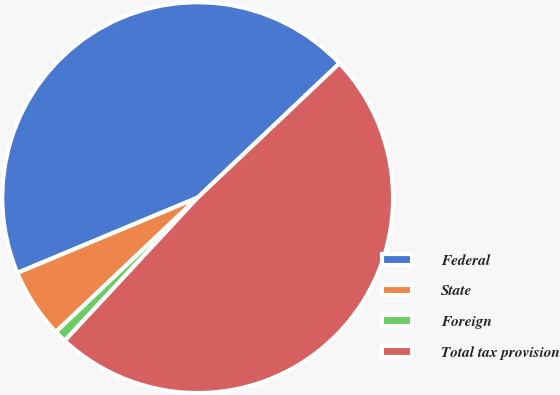Convert chart to OTSL. <chart><loc_0><loc_0><loc_500><loc_500><pie_chart><fcel>Federal<fcel>State<fcel>Foreign<fcel>Total tax provision<nl><fcel>44.23%<fcel>5.77%<fcel>1.02%<fcel>48.98%<nl></chart> 